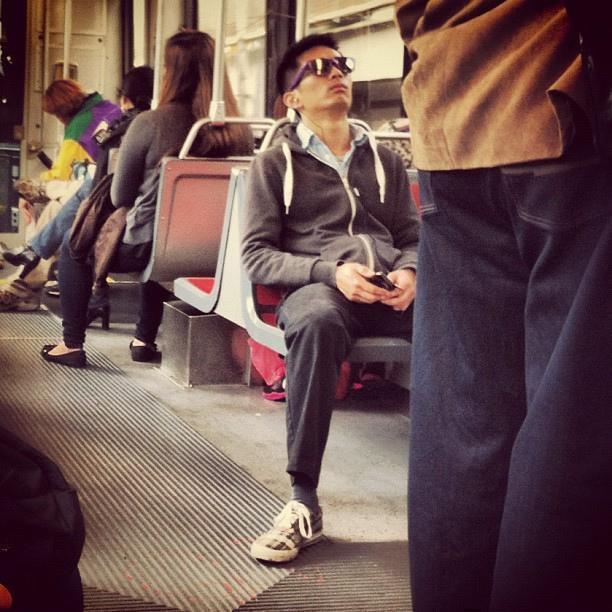How is the boy's sweater done up?
Indicate the correct response by choosing from the four available options to answer the question.
Options: Buttons, velcro, zipper, buckles. Zipper. 